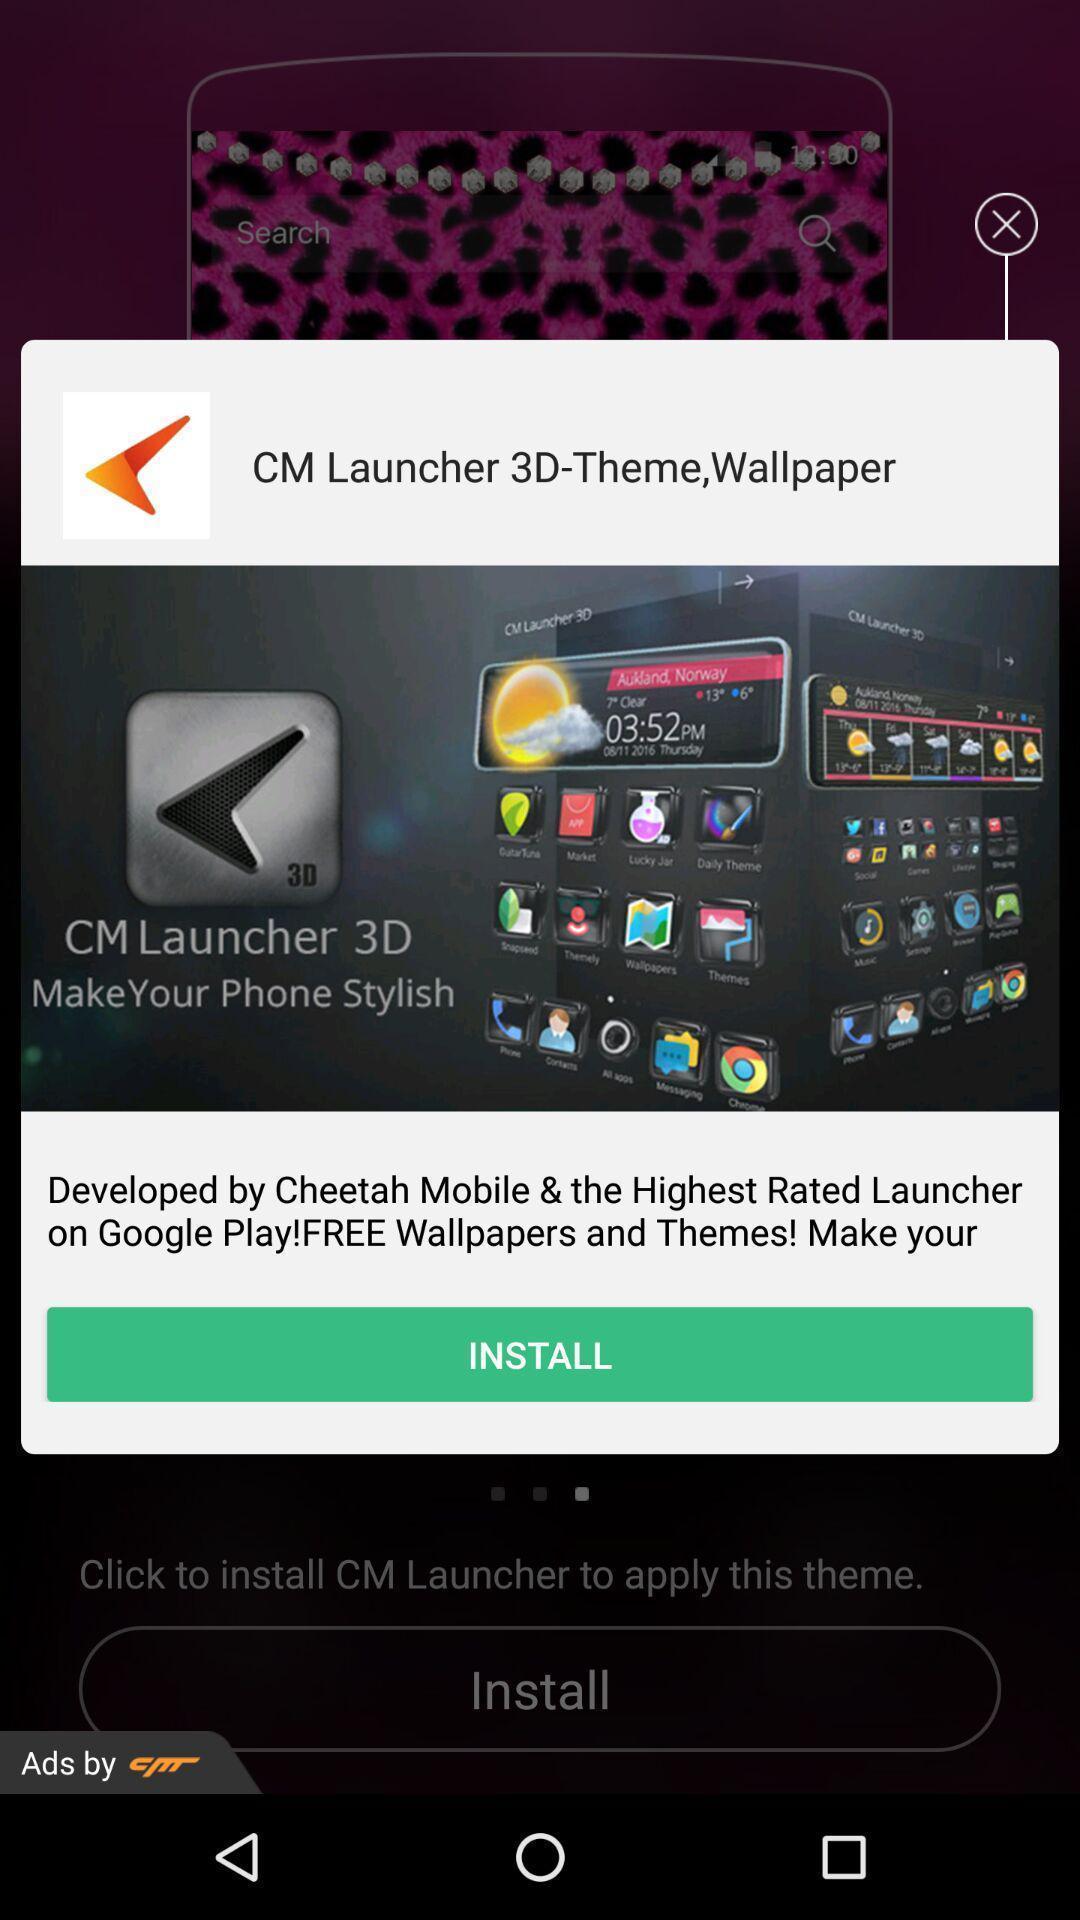Explain the elements present in this screenshot. Popup showing few information with install button. 